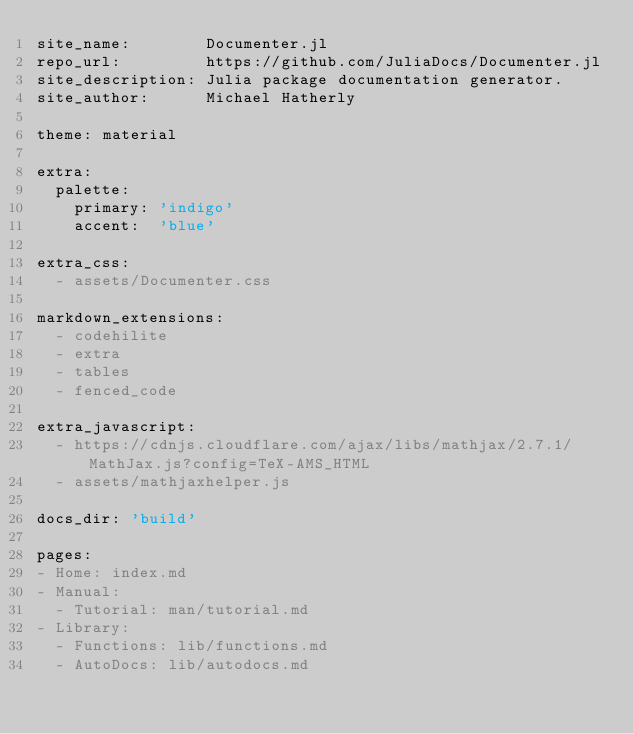<code> <loc_0><loc_0><loc_500><loc_500><_YAML_>site_name:        Documenter.jl
repo_url:         https://github.com/JuliaDocs/Documenter.jl
site_description: Julia package documentation generator.
site_author:      Michael Hatherly

theme: material

extra:
  palette:
    primary: 'indigo'
    accent:  'blue'

extra_css:
  - assets/Documenter.css

markdown_extensions:
  - codehilite
  - extra
  - tables
  - fenced_code

extra_javascript:
  - https://cdnjs.cloudflare.com/ajax/libs/mathjax/2.7.1/MathJax.js?config=TeX-AMS_HTML
  - assets/mathjaxhelper.js

docs_dir: 'build'

pages:
- Home: index.md
- Manual:
  - Tutorial: man/tutorial.md
- Library:
  - Functions: lib/functions.md
  - AutoDocs: lib/autodocs.md
</code> 